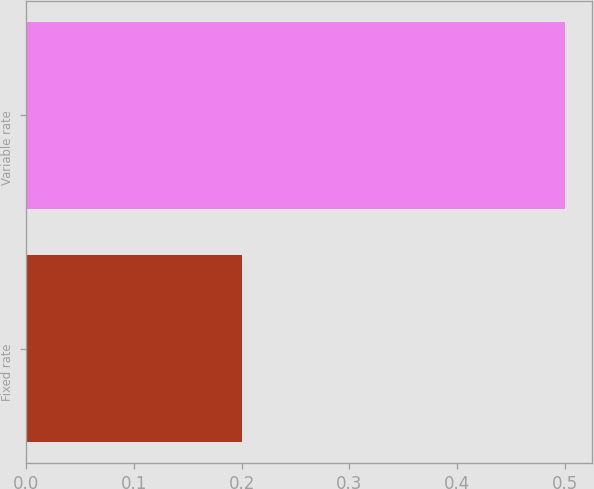<chart> <loc_0><loc_0><loc_500><loc_500><bar_chart><fcel>Fixed rate<fcel>Variable rate<nl><fcel>0.2<fcel>0.5<nl></chart> 